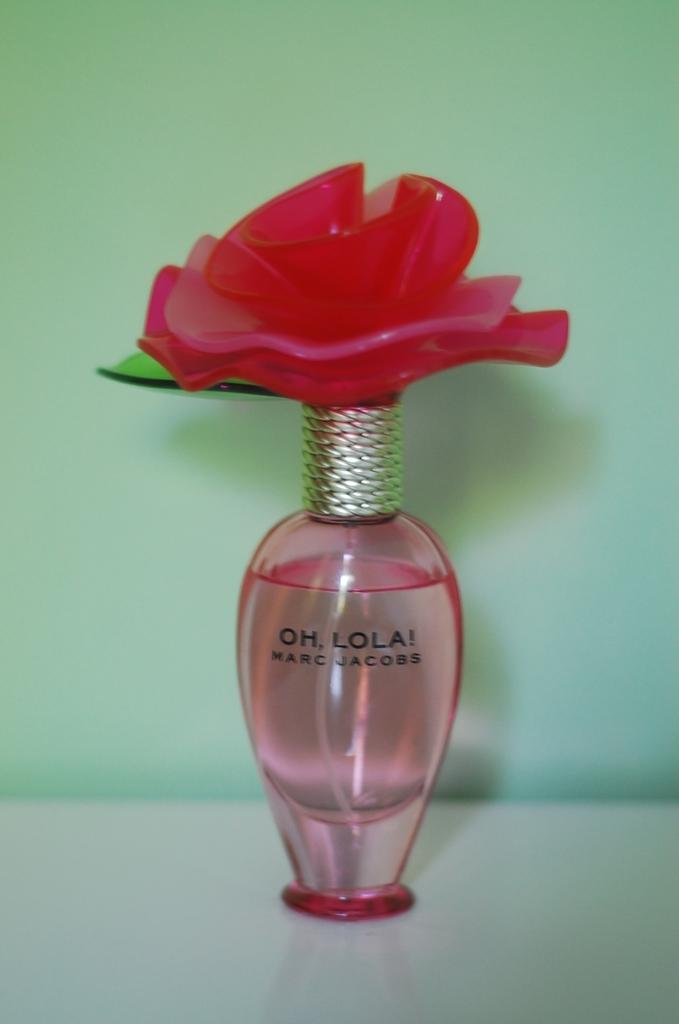<image>
Present a compact description of the photo's key features. A Marc Jacobs perfume with a flower on top is on a white surface. 